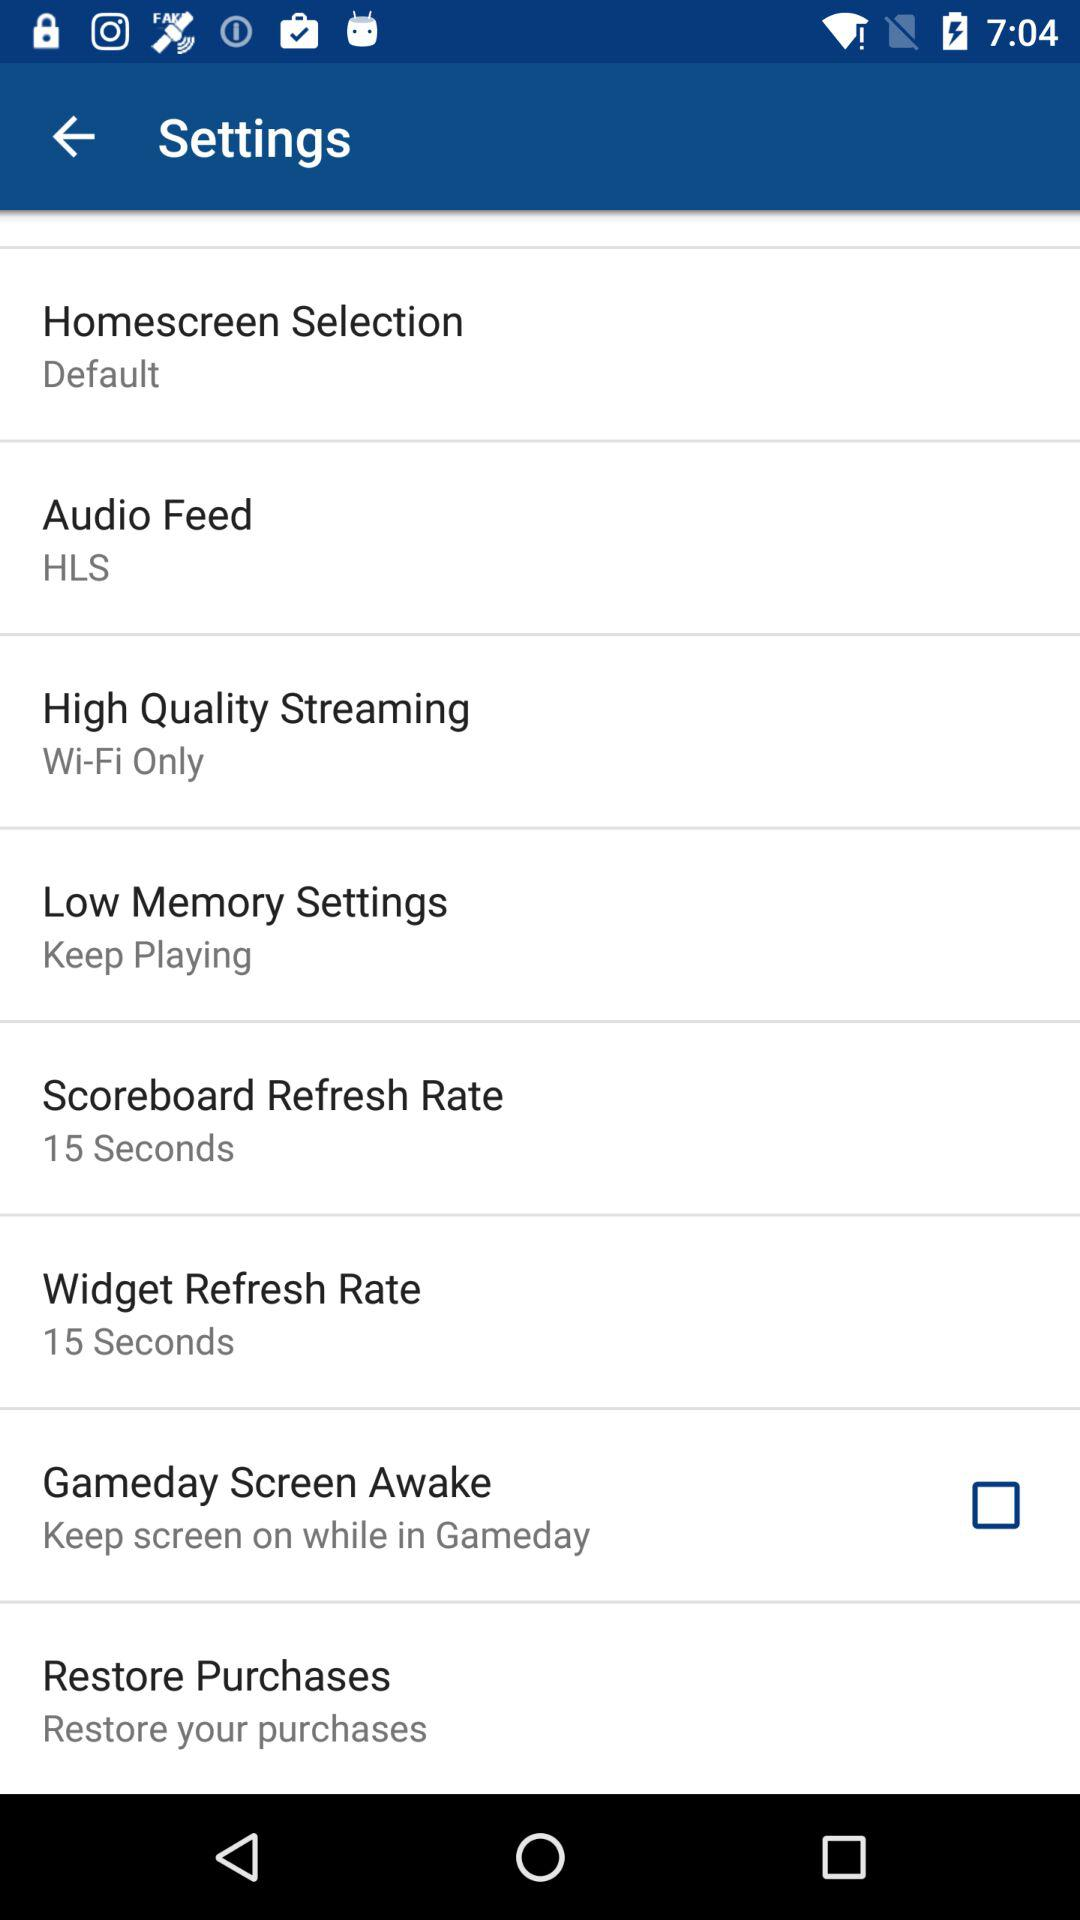What's the setting for "Scoreboard Refresh Rate"? The setting for "Scoreboard Refresh Rate" is "15 Seconds". 